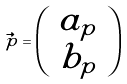Convert formula to latex. <formula><loc_0><loc_0><loc_500><loc_500>\vec { p } = \left ( \begin{array} { c } a _ { p } \\ b _ { p } \end{array} \right )</formula> 